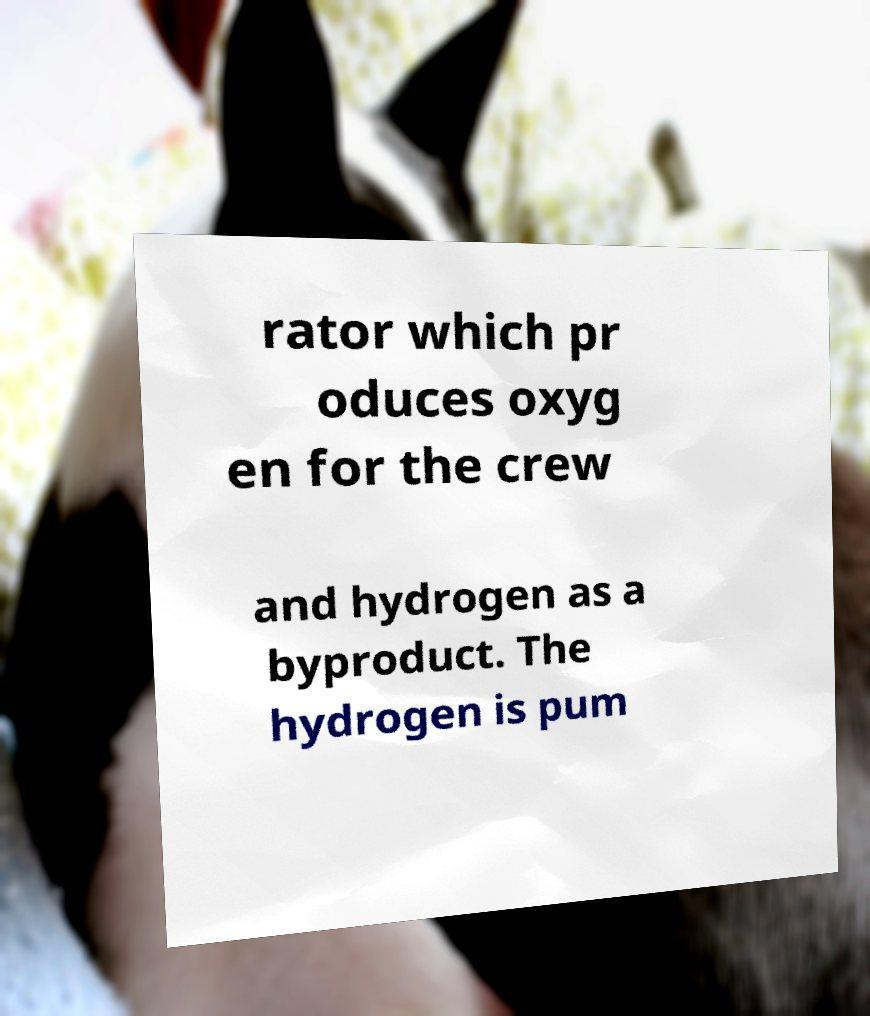What messages or text are displayed in this image? I need them in a readable, typed format. rator which pr oduces oxyg en for the crew and hydrogen as a byproduct. The hydrogen is pum 